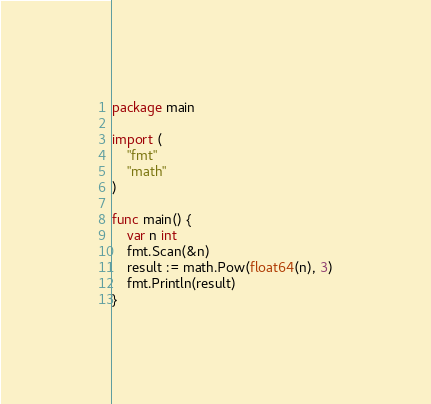<code> <loc_0><loc_0><loc_500><loc_500><_Go_>package main

import (
	"fmt"
	"math"
)

func main() {
	var n int
	fmt.Scan(&n)
	result := math.Pow(float64(n), 3)
	fmt.Println(result)
}
</code> 